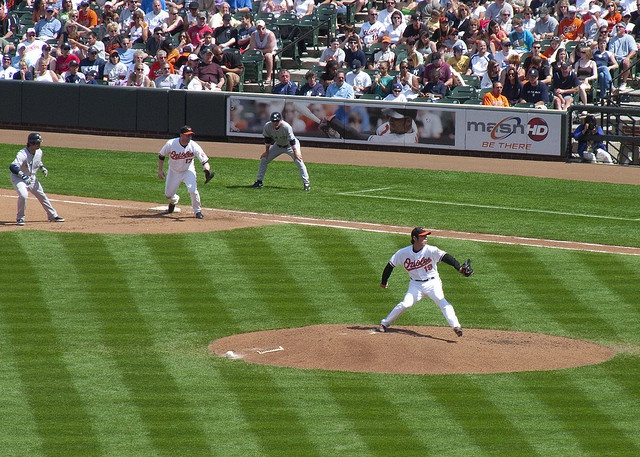Describe the objects in this image and their specific colors. I can see people in black, gray, white, and darkgray tones, people in black, white, and darkgray tones, people in black, darkgray, white, and gray tones, people in black, gray, white, and darkgreen tones, and people in black, gray, lightgray, and darkgray tones in this image. 